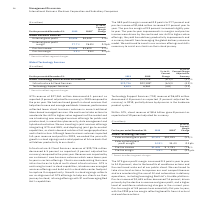According to International Business Machines's financial document, What caused the decrease in the pre-tax income in 2019? The year-to-year improvements in margins and pre-tax income were driven by the continued mix shift to higher-value offerings, the yield from delivery productivity improvements and a currency benefit from leveraging the global delivery resource model.. The document states: "in of 9.9 percent increased slightly year to year. The year-to-year improvements in margins and pre-tax income were driven by the continued mix shift ..." Also, What was the pre-tax margin of 2019? According to the financial document, 9.9%. The relevant text states: "Pre-tax margin 9.9% 9.6% 0.2 pts...." Also, What was the External gross profit margin in 2019? According to the financial document, 27.7%. The relevant text states: "External gross profit margin 27.7% 26.8% 0.9 pts...." Also, can you calculate: What were the average External total gross profit? To answer this question, I need to perform calculations using the financial data. The calculation is: (4,606+4,448) / 2, which equals 4527 (in millions). This is based on the information: "External gross profit $4,606 $4,448 3.5% External gross profit $4,606 $4,448 3.5%..." The key data points involved are: 4,448, 4,606. Also, can you calculate: What was the increase / (decrease) in the Pre-tax income from 2018 to 2019? Based on the calculation: 1,666 - 1,629, the result is 37 (in millions). This is based on the information: "Pre-tax income $1,666 $1,629 2.2% Pre-tax income $1,666 $1,629 2.2%..." The key data points involved are: 1,629, 1,666. Also, can you calculate: What was the increase / (decrease) in the Pre-tax margin from 2018 to 2019? Based on the calculation: 9.9% - 9.6%, the result is 0.3 (percentage). This is based on the information: "Pre-tax margin 9.9% 9.6% 0.2 pts. Pre-tax margin 9.9% 9.6% 0.2 pts...." The key data points involved are: 9.6, 9.9. 